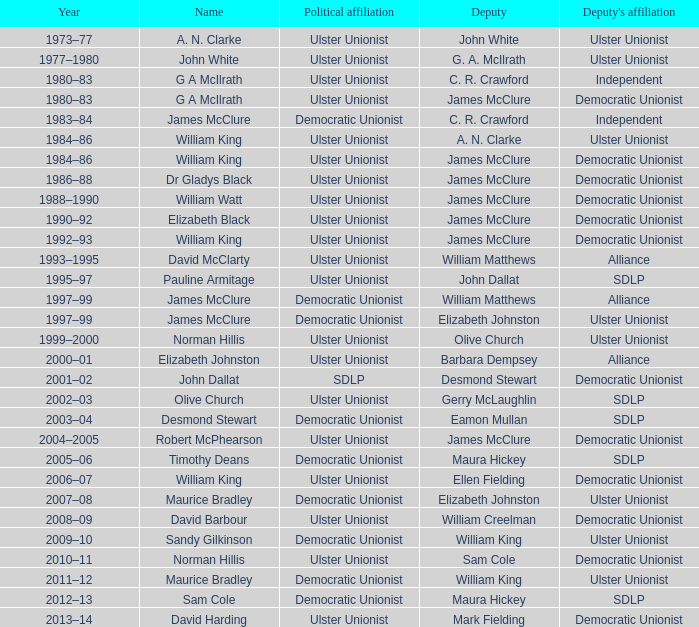What is the Name for 1997–99? James McClure, James McClure. 